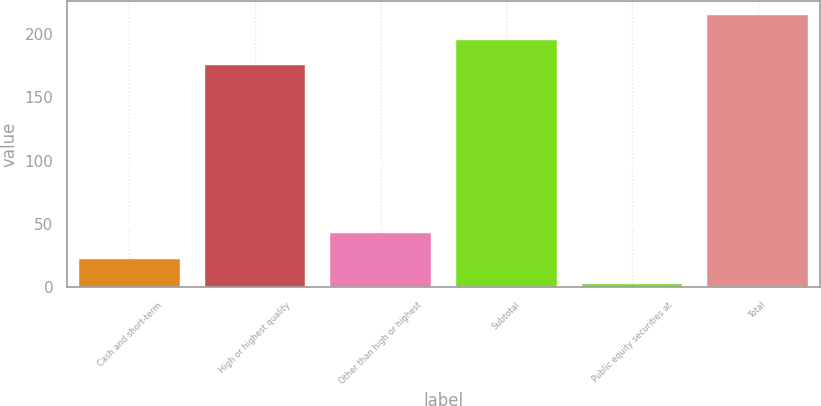<chart> <loc_0><loc_0><loc_500><loc_500><bar_chart><fcel>Cash and short-term<fcel>High or highest quality<fcel>Other than high or highest<fcel>Subtotal<fcel>Public equity securities at<fcel>Total<nl><fcel>22.86<fcel>175.1<fcel>42.92<fcel>195.16<fcel>2.8<fcel>215.22<nl></chart> 